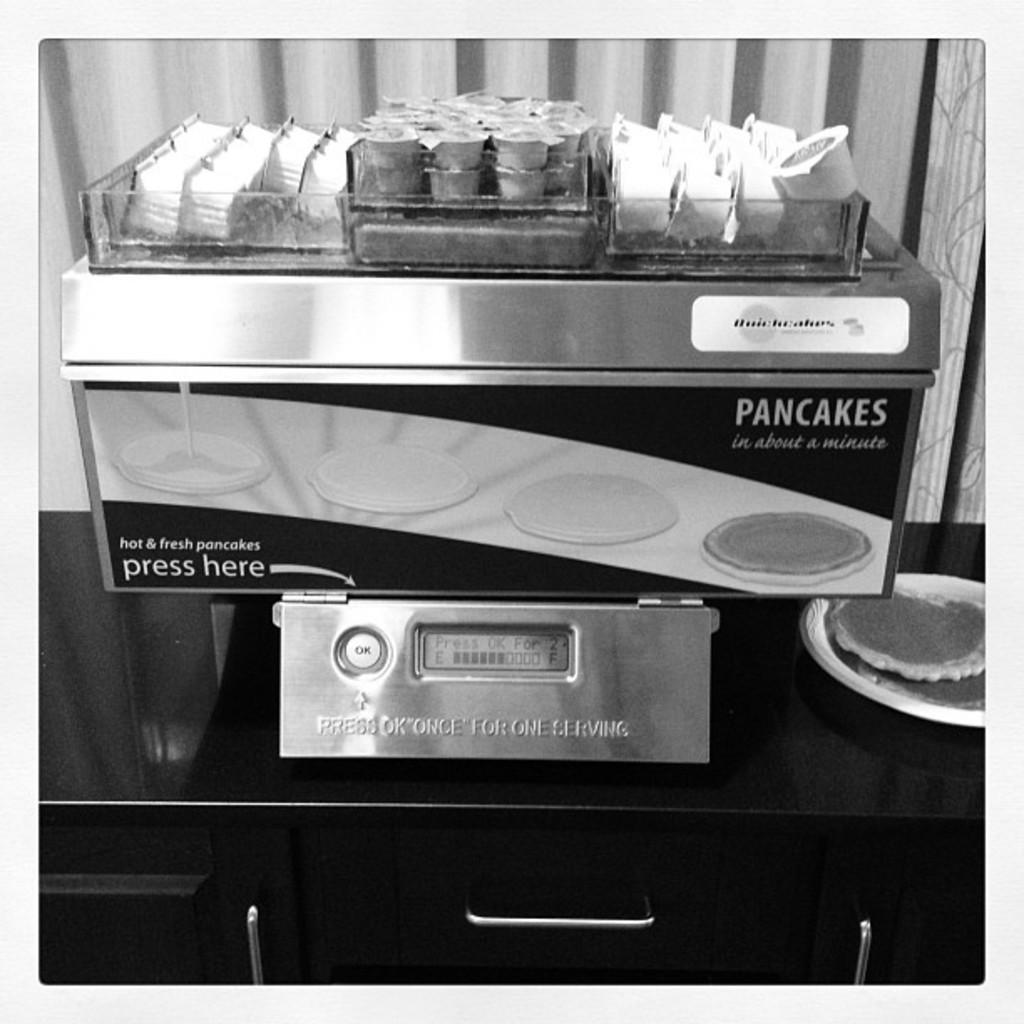What does this machine serve?
Your response must be concise. Pancakes. How long does it take it to make pancakes?
Give a very brief answer. About a minute. 